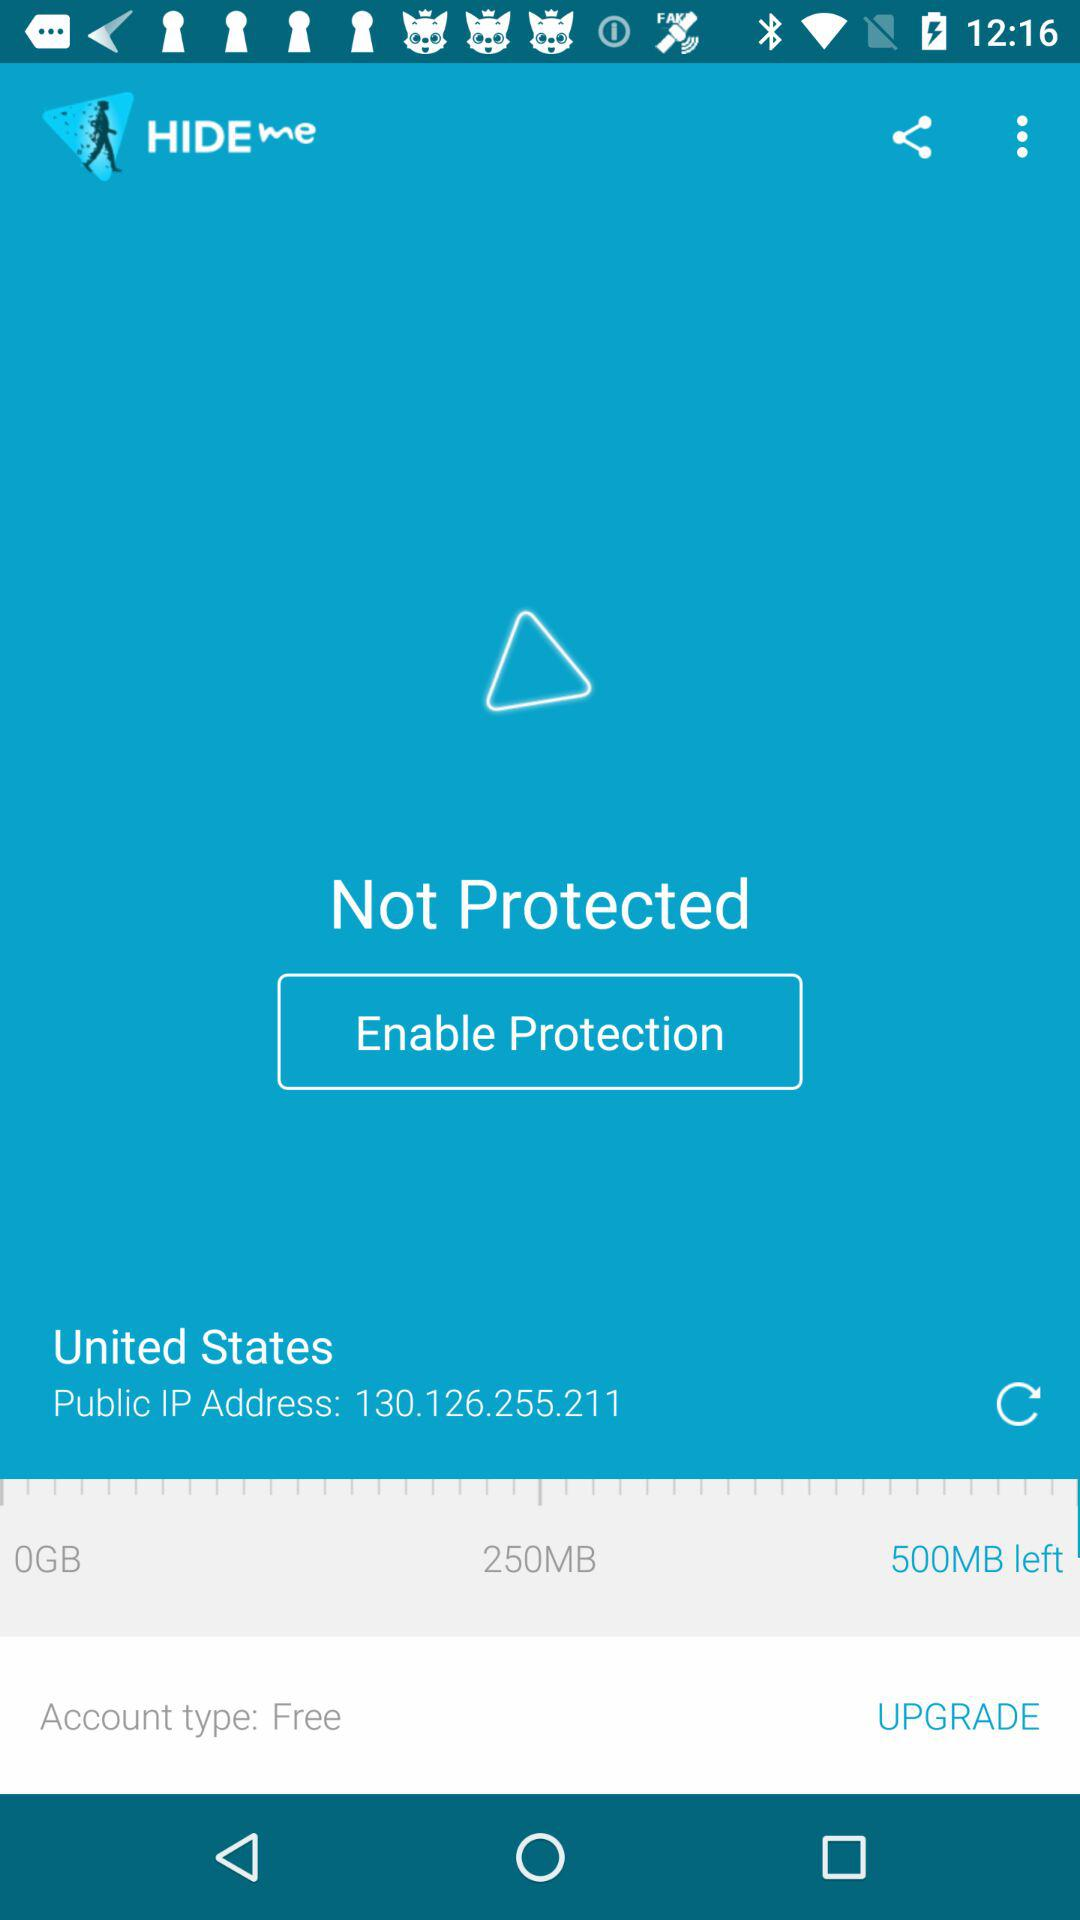What is the account type? The account type is "Free". 